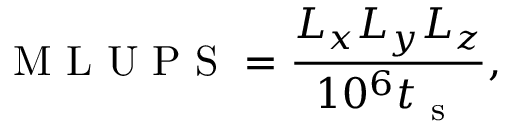<formula> <loc_0><loc_0><loc_500><loc_500>M L U P S = \frac { L _ { x } L _ { y } L _ { z } } { 1 0 ^ { 6 } t _ { s } } ,</formula> 